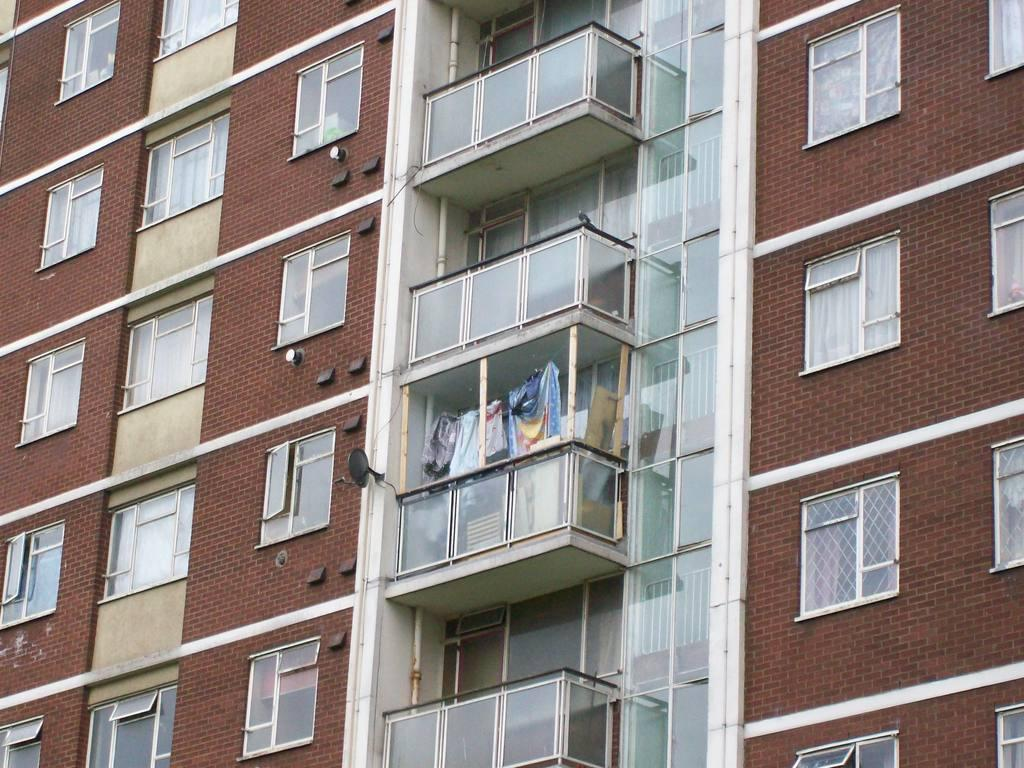What type of structure is shown in the image? The image shows an outside view of a building. What can be seen in the windows of the building? There are windows with glasses in the building. Are there any window treatments visible in the image? Yes, curtains are present in the windows. What architectural feature is present in the building? There are glass balconies in the building. Can you see a cake on the glass balcony in the image? There is no cake present on the glass balcony in the image. Is there a cactus visible in the windows of the building? There is no cactus visible in the windows of the building; only curtains are present. 